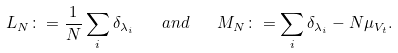<formula> <loc_0><loc_0><loc_500><loc_500>L _ { N } \colon = \frac { 1 } { N } \sum _ { i } \delta _ { \lambda _ { i } } \quad a n d \quad M _ { N } \colon = \sum _ { i } \delta _ { \lambda _ { i } } - N \mu _ { V _ { t } } .</formula> 